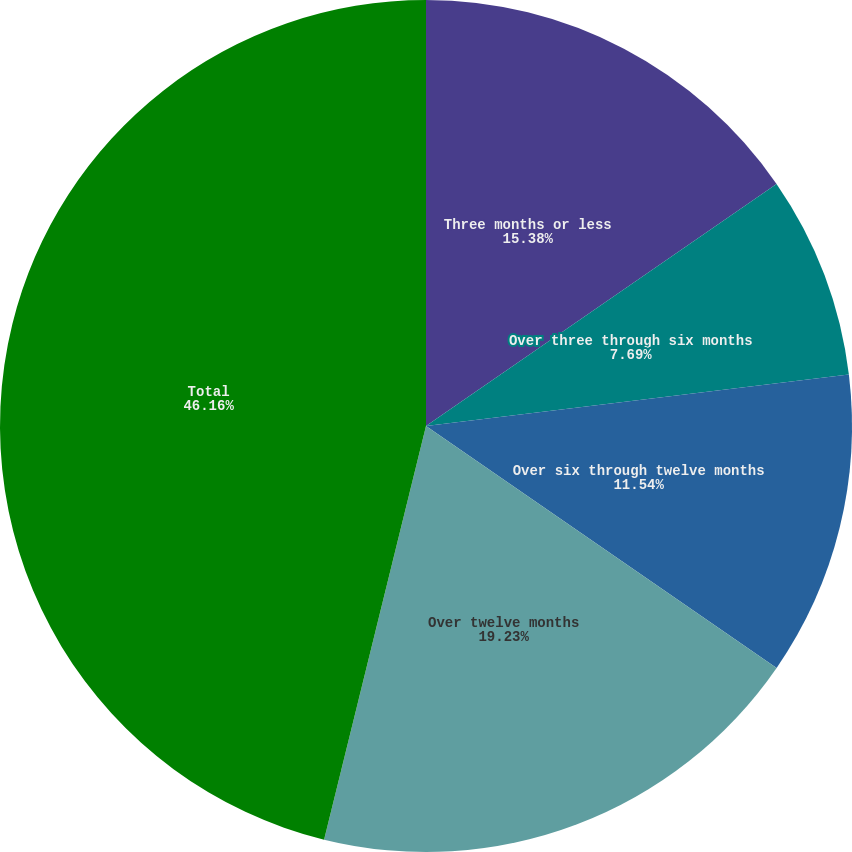Convert chart to OTSL. <chart><loc_0><loc_0><loc_500><loc_500><pie_chart><fcel>Three months or less<fcel>Over three through six months<fcel>Over six through twelve months<fcel>Over twelve months<fcel>Total<nl><fcel>15.38%<fcel>7.69%<fcel>11.54%<fcel>19.23%<fcel>46.15%<nl></chart> 